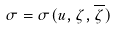Convert formula to latex. <formula><loc_0><loc_0><loc_500><loc_500>\sigma = \sigma ( u , \zeta , \overline { \zeta } )</formula> 